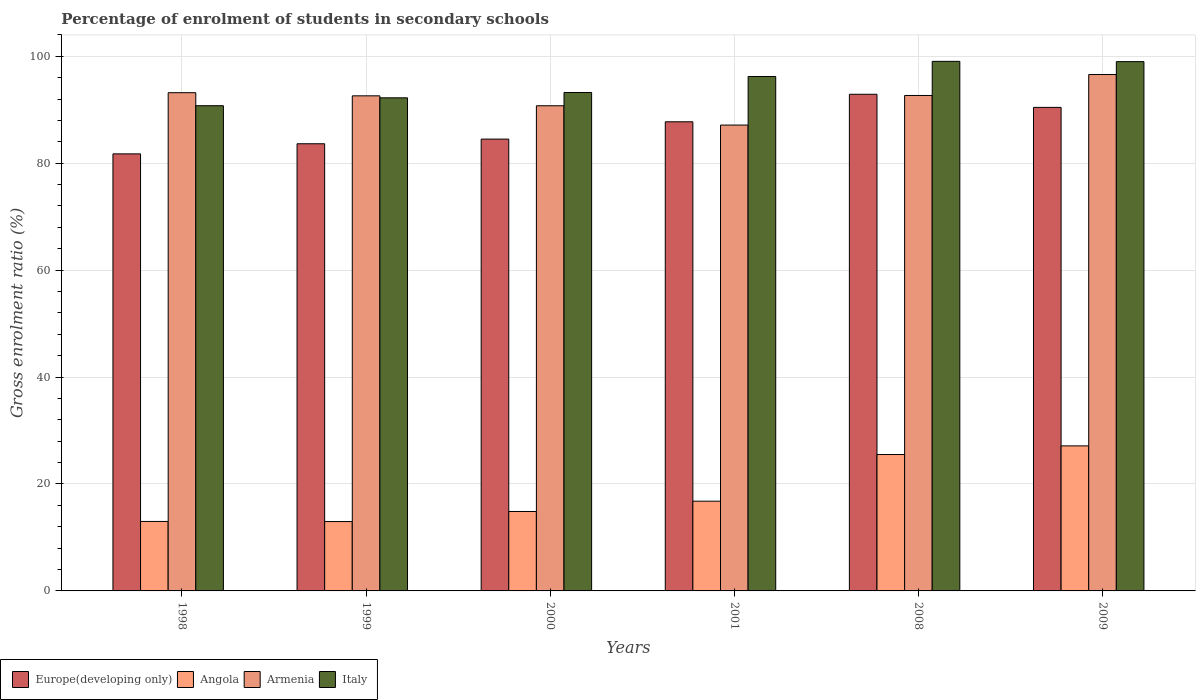How many different coloured bars are there?
Provide a succinct answer. 4. How many groups of bars are there?
Your answer should be very brief. 6. How many bars are there on the 3rd tick from the left?
Your answer should be very brief. 4. In how many cases, is the number of bars for a given year not equal to the number of legend labels?
Give a very brief answer. 0. What is the percentage of students enrolled in secondary schools in Italy in 1999?
Your answer should be very brief. 92.23. Across all years, what is the maximum percentage of students enrolled in secondary schools in Italy?
Your answer should be compact. 99.05. Across all years, what is the minimum percentage of students enrolled in secondary schools in Europe(developing only)?
Your response must be concise. 81.75. In which year was the percentage of students enrolled in secondary schools in Italy maximum?
Offer a terse response. 2008. In which year was the percentage of students enrolled in secondary schools in Armenia minimum?
Ensure brevity in your answer.  2001. What is the total percentage of students enrolled in secondary schools in Italy in the graph?
Provide a succinct answer. 570.5. What is the difference between the percentage of students enrolled in secondary schools in Angola in 2008 and that in 2009?
Ensure brevity in your answer.  -1.62. What is the difference between the percentage of students enrolled in secondary schools in Europe(developing only) in 2008 and the percentage of students enrolled in secondary schools in Angola in 2001?
Your response must be concise. 76.11. What is the average percentage of students enrolled in secondary schools in Armenia per year?
Your answer should be very brief. 92.16. In the year 2009, what is the difference between the percentage of students enrolled in secondary schools in Angola and percentage of students enrolled in secondary schools in Italy?
Offer a very short reply. -71.87. What is the ratio of the percentage of students enrolled in secondary schools in Italy in 1998 to that in 2008?
Your answer should be compact. 0.92. Is the difference between the percentage of students enrolled in secondary schools in Angola in 2000 and 2008 greater than the difference between the percentage of students enrolled in secondary schools in Italy in 2000 and 2008?
Make the answer very short. No. What is the difference between the highest and the second highest percentage of students enrolled in secondary schools in Italy?
Provide a short and direct response. 0.05. What is the difference between the highest and the lowest percentage of students enrolled in secondary schools in Angola?
Offer a terse response. 14.15. What does the 1st bar from the left in 2008 represents?
Provide a succinct answer. Europe(developing only). What does the 3rd bar from the right in 2001 represents?
Give a very brief answer. Angola. Does the graph contain any zero values?
Offer a terse response. No. Where does the legend appear in the graph?
Keep it short and to the point. Bottom left. What is the title of the graph?
Offer a very short reply. Percentage of enrolment of students in secondary schools. What is the label or title of the X-axis?
Your response must be concise. Years. What is the Gross enrolment ratio (%) of Europe(developing only) in 1998?
Offer a terse response. 81.75. What is the Gross enrolment ratio (%) of Angola in 1998?
Ensure brevity in your answer.  12.99. What is the Gross enrolment ratio (%) in Armenia in 1998?
Offer a very short reply. 93.19. What is the Gross enrolment ratio (%) of Italy in 1998?
Your answer should be compact. 90.76. What is the Gross enrolment ratio (%) of Europe(developing only) in 1999?
Ensure brevity in your answer.  83.64. What is the Gross enrolment ratio (%) in Angola in 1999?
Keep it short and to the point. 12.98. What is the Gross enrolment ratio (%) of Armenia in 1999?
Give a very brief answer. 92.6. What is the Gross enrolment ratio (%) in Italy in 1999?
Your answer should be compact. 92.23. What is the Gross enrolment ratio (%) in Europe(developing only) in 2000?
Ensure brevity in your answer.  84.51. What is the Gross enrolment ratio (%) in Angola in 2000?
Your response must be concise. 14.86. What is the Gross enrolment ratio (%) of Armenia in 2000?
Provide a succinct answer. 90.75. What is the Gross enrolment ratio (%) of Italy in 2000?
Provide a short and direct response. 93.23. What is the Gross enrolment ratio (%) of Europe(developing only) in 2001?
Provide a short and direct response. 87.75. What is the Gross enrolment ratio (%) in Angola in 2001?
Your response must be concise. 16.78. What is the Gross enrolment ratio (%) in Armenia in 2001?
Keep it short and to the point. 87.14. What is the Gross enrolment ratio (%) of Italy in 2001?
Your answer should be compact. 96.22. What is the Gross enrolment ratio (%) of Europe(developing only) in 2008?
Provide a short and direct response. 92.9. What is the Gross enrolment ratio (%) of Angola in 2008?
Offer a terse response. 25.51. What is the Gross enrolment ratio (%) in Armenia in 2008?
Your answer should be compact. 92.67. What is the Gross enrolment ratio (%) in Italy in 2008?
Your response must be concise. 99.05. What is the Gross enrolment ratio (%) in Europe(developing only) in 2009?
Offer a very short reply. 90.44. What is the Gross enrolment ratio (%) of Angola in 2009?
Provide a short and direct response. 27.13. What is the Gross enrolment ratio (%) of Armenia in 2009?
Your response must be concise. 96.59. What is the Gross enrolment ratio (%) of Italy in 2009?
Offer a terse response. 99. Across all years, what is the maximum Gross enrolment ratio (%) of Europe(developing only)?
Keep it short and to the point. 92.9. Across all years, what is the maximum Gross enrolment ratio (%) in Angola?
Provide a short and direct response. 27.13. Across all years, what is the maximum Gross enrolment ratio (%) in Armenia?
Keep it short and to the point. 96.59. Across all years, what is the maximum Gross enrolment ratio (%) of Italy?
Your response must be concise. 99.05. Across all years, what is the minimum Gross enrolment ratio (%) of Europe(developing only)?
Provide a short and direct response. 81.75. Across all years, what is the minimum Gross enrolment ratio (%) of Angola?
Offer a very short reply. 12.98. Across all years, what is the minimum Gross enrolment ratio (%) in Armenia?
Ensure brevity in your answer.  87.14. Across all years, what is the minimum Gross enrolment ratio (%) of Italy?
Your response must be concise. 90.76. What is the total Gross enrolment ratio (%) of Europe(developing only) in the graph?
Your answer should be very brief. 520.99. What is the total Gross enrolment ratio (%) of Angola in the graph?
Make the answer very short. 110.25. What is the total Gross enrolment ratio (%) of Armenia in the graph?
Provide a short and direct response. 552.95. What is the total Gross enrolment ratio (%) in Italy in the graph?
Make the answer very short. 570.5. What is the difference between the Gross enrolment ratio (%) of Europe(developing only) in 1998 and that in 1999?
Offer a very short reply. -1.89. What is the difference between the Gross enrolment ratio (%) of Angola in 1998 and that in 1999?
Your answer should be compact. 0.02. What is the difference between the Gross enrolment ratio (%) in Armenia in 1998 and that in 1999?
Provide a succinct answer. 0.59. What is the difference between the Gross enrolment ratio (%) in Italy in 1998 and that in 1999?
Ensure brevity in your answer.  -1.48. What is the difference between the Gross enrolment ratio (%) of Europe(developing only) in 1998 and that in 2000?
Keep it short and to the point. -2.76. What is the difference between the Gross enrolment ratio (%) in Angola in 1998 and that in 2000?
Keep it short and to the point. -1.86. What is the difference between the Gross enrolment ratio (%) in Armenia in 1998 and that in 2000?
Keep it short and to the point. 2.44. What is the difference between the Gross enrolment ratio (%) in Italy in 1998 and that in 2000?
Offer a terse response. -2.47. What is the difference between the Gross enrolment ratio (%) in Europe(developing only) in 1998 and that in 2001?
Make the answer very short. -6. What is the difference between the Gross enrolment ratio (%) in Angola in 1998 and that in 2001?
Your answer should be compact. -3.79. What is the difference between the Gross enrolment ratio (%) in Armenia in 1998 and that in 2001?
Keep it short and to the point. 6.06. What is the difference between the Gross enrolment ratio (%) of Italy in 1998 and that in 2001?
Your answer should be compact. -5.47. What is the difference between the Gross enrolment ratio (%) in Europe(developing only) in 1998 and that in 2008?
Your response must be concise. -11.15. What is the difference between the Gross enrolment ratio (%) of Angola in 1998 and that in 2008?
Your answer should be compact. -12.52. What is the difference between the Gross enrolment ratio (%) in Armenia in 1998 and that in 2008?
Give a very brief answer. 0.52. What is the difference between the Gross enrolment ratio (%) of Italy in 1998 and that in 2008?
Keep it short and to the point. -8.3. What is the difference between the Gross enrolment ratio (%) in Europe(developing only) in 1998 and that in 2009?
Offer a terse response. -8.69. What is the difference between the Gross enrolment ratio (%) of Angola in 1998 and that in 2009?
Your answer should be very brief. -14.13. What is the difference between the Gross enrolment ratio (%) of Armenia in 1998 and that in 2009?
Offer a terse response. -3.4. What is the difference between the Gross enrolment ratio (%) in Italy in 1998 and that in 2009?
Ensure brevity in your answer.  -8.25. What is the difference between the Gross enrolment ratio (%) in Europe(developing only) in 1999 and that in 2000?
Keep it short and to the point. -0.87. What is the difference between the Gross enrolment ratio (%) of Angola in 1999 and that in 2000?
Your answer should be very brief. -1.88. What is the difference between the Gross enrolment ratio (%) of Armenia in 1999 and that in 2000?
Ensure brevity in your answer.  1.85. What is the difference between the Gross enrolment ratio (%) in Italy in 1999 and that in 2000?
Give a very brief answer. -1. What is the difference between the Gross enrolment ratio (%) in Europe(developing only) in 1999 and that in 2001?
Provide a succinct answer. -4.11. What is the difference between the Gross enrolment ratio (%) of Angola in 1999 and that in 2001?
Provide a short and direct response. -3.81. What is the difference between the Gross enrolment ratio (%) of Armenia in 1999 and that in 2001?
Make the answer very short. 5.47. What is the difference between the Gross enrolment ratio (%) in Italy in 1999 and that in 2001?
Make the answer very short. -3.99. What is the difference between the Gross enrolment ratio (%) in Europe(developing only) in 1999 and that in 2008?
Ensure brevity in your answer.  -9.26. What is the difference between the Gross enrolment ratio (%) of Angola in 1999 and that in 2008?
Your answer should be very brief. -12.54. What is the difference between the Gross enrolment ratio (%) of Armenia in 1999 and that in 2008?
Provide a short and direct response. -0.07. What is the difference between the Gross enrolment ratio (%) of Italy in 1999 and that in 2008?
Your answer should be very brief. -6.82. What is the difference between the Gross enrolment ratio (%) of Europe(developing only) in 1999 and that in 2009?
Provide a short and direct response. -6.8. What is the difference between the Gross enrolment ratio (%) of Angola in 1999 and that in 2009?
Make the answer very short. -14.15. What is the difference between the Gross enrolment ratio (%) in Armenia in 1999 and that in 2009?
Make the answer very short. -3.99. What is the difference between the Gross enrolment ratio (%) of Italy in 1999 and that in 2009?
Provide a short and direct response. -6.77. What is the difference between the Gross enrolment ratio (%) of Europe(developing only) in 2000 and that in 2001?
Provide a short and direct response. -3.24. What is the difference between the Gross enrolment ratio (%) in Angola in 2000 and that in 2001?
Your response must be concise. -1.93. What is the difference between the Gross enrolment ratio (%) of Armenia in 2000 and that in 2001?
Provide a succinct answer. 3.61. What is the difference between the Gross enrolment ratio (%) of Italy in 2000 and that in 2001?
Your answer should be compact. -2.99. What is the difference between the Gross enrolment ratio (%) of Europe(developing only) in 2000 and that in 2008?
Keep it short and to the point. -8.38. What is the difference between the Gross enrolment ratio (%) in Angola in 2000 and that in 2008?
Make the answer very short. -10.65. What is the difference between the Gross enrolment ratio (%) in Armenia in 2000 and that in 2008?
Keep it short and to the point. -1.92. What is the difference between the Gross enrolment ratio (%) in Italy in 2000 and that in 2008?
Your answer should be compact. -5.82. What is the difference between the Gross enrolment ratio (%) in Europe(developing only) in 2000 and that in 2009?
Offer a terse response. -5.93. What is the difference between the Gross enrolment ratio (%) of Angola in 2000 and that in 2009?
Give a very brief answer. -12.27. What is the difference between the Gross enrolment ratio (%) in Armenia in 2000 and that in 2009?
Provide a succinct answer. -5.84. What is the difference between the Gross enrolment ratio (%) in Italy in 2000 and that in 2009?
Give a very brief answer. -5.77. What is the difference between the Gross enrolment ratio (%) in Europe(developing only) in 2001 and that in 2008?
Keep it short and to the point. -5.15. What is the difference between the Gross enrolment ratio (%) in Angola in 2001 and that in 2008?
Offer a terse response. -8.73. What is the difference between the Gross enrolment ratio (%) in Armenia in 2001 and that in 2008?
Provide a short and direct response. -5.54. What is the difference between the Gross enrolment ratio (%) of Italy in 2001 and that in 2008?
Your response must be concise. -2.83. What is the difference between the Gross enrolment ratio (%) of Europe(developing only) in 2001 and that in 2009?
Offer a terse response. -2.69. What is the difference between the Gross enrolment ratio (%) of Angola in 2001 and that in 2009?
Keep it short and to the point. -10.34. What is the difference between the Gross enrolment ratio (%) of Armenia in 2001 and that in 2009?
Offer a terse response. -9.45. What is the difference between the Gross enrolment ratio (%) in Italy in 2001 and that in 2009?
Make the answer very short. -2.78. What is the difference between the Gross enrolment ratio (%) in Europe(developing only) in 2008 and that in 2009?
Offer a terse response. 2.45. What is the difference between the Gross enrolment ratio (%) of Angola in 2008 and that in 2009?
Provide a short and direct response. -1.62. What is the difference between the Gross enrolment ratio (%) in Armenia in 2008 and that in 2009?
Ensure brevity in your answer.  -3.92. What is the difference between the Gross enrolment ratio (%) in Italy in 2008 and that in 2009?
Give a very brief answer. 0.05. What is the difference between the Gross enrolment ratio (%) in Europe(developing only) in 1998 and the Gross enrolment ratio (%) in Angola in 1999?
Give a very brief answer. 68.77. What is the difference between the Gross enrolment ratio (%) of Europe(developing only) in 1998 and the Gross enrolment ratio (%) of Armenia in 1999?
Make the answer very short. -10.86. What is the difference between the Gross enrolment ratio (%) of Europe(developing only) in 1998 and the Gross enrolment ratio (%) of Italy in 1999?
Offer a very short reply. -10.48. What is the difference between the Gross enrolment ratio (%) in Angola in 1998 and the Gross enrolment ratio (%) in Armenia in 1999?
Provide a short and direct response. -79.61. What is the difference between the Gross enrolment ratio (%) in Angola in 1998 and the Gross enrolment ratio (%) in Italy in 1999?
Ensure brevity in your answer.  -79.24. What is the difference between the Gross enrolment ratio (%) of Armenia in 1998 and the Gross enrolment ratio (%) of Italy in 1999?
Offer a terse response. 0.96. What is the difference between the Gross enrolment ratio (%) in Europe(developing only) in 1998 and the Gross enrolment ratio (%) in Angola in 2000?
Offer a terse response. 66.89. What is the difference between the Gross enrolment ratio (%) of Europe(developing only) in 1998 and the Gross enrolment ratio (%) of Armenia in 2000?
Make the answer very short. -9. What is the difference between the Gross enrolment ratio (%) of Europe(developing only) in 1998 and the Gross enrolment ratio (%) of Italy in 2000?
Make the answer very short. -11.48. What is the difference between the Gross enrolment ratio (%) in Angola in 1998 and the Gross enrolment ratio (%) in Armenia in 2000?
Offer a terse response. -77.76. What is the difference between the Gross enrolment ratio (%) in Angola in 1998 and the Gross enrolment ratio (%) in Italy in 2000?
Offer a very short reply. -80.24. What is the difference between the Gross enrolment ratio (%) of Armenia in 1998 and the Gross enrolment ratio (%) of Italy in 2000?
Ensure brevity in your answer.  -0.04. What is the difference between the Gross enrolment ratio (%) in Europe(developing only) in 1998 and the Gross enrolment ratio (%) in Angola in 2001?
Make the answer very short. 64.97. What is the difference between the Gross enrolment ratio (%) in Europe(developing only) in 1998 and the Gross enrolment ratio (%) in Armenia in 2001?
Provide a succinct answer. -5.39. What is the difference between the Gross enrolment ratio (%) in Europe(developing only) in 1998 and the Gross enrolment ratio (%) in Italy in 2001?
Your answer should be very brief. -14.47. What is the difference between the Gross enrolment ratio (%) in Angola in 1998 and the Gross enrolment ratio (%) in Armenia in 2001?
Keep it short and to the point. -74.14. What is the difference between the Gross enrolment ratio (%) in Angola in 1998 and the Gross enrolment ratio (%) in Italy in 2001?
Provide a succinct answer. -83.23. What is the difference between the Gross enrolment ratio (%) of Armenia in 1998 and the Gross enrolment ratio (%) of Italy in 2001?
Your answer should be very brief. -3.03. What is the difference between the Gross enrolment ratio (%) of Europe(developing only) in 1998 and the Gross enrolment ratio (%) of Angola in 2008?
Keep it short and to the point. 56.24. What is the difference between the Gross enrolment ratio (%) of Europe(developing only) in 1998 and the Gross enrolment ratio (%) of Armenia in 2008?
Your answer should be compact. -10.92. What is the difference between the Gross enrolment ratio (%) in Europe(developing only) in 1998 and the Gross enrolment ratio (%) in Italy in 2008?
Give a very brief answer. -17.31. What is the difference between the Gross enrolment ratio (%) in Angola in 1998 and the Gross enrolment ratio (%) in Armenia in 2008?
Your answer should be compact. -79.68. What is the difference between the Gross enrolment ratio (%) in Angola in 1998 and the Gross enrolment ratio (%) in Italy in 2008?
Provide a succinct answer. -86.06. What is the difference between the Gross enrolment ratio (%) of Armenia in 1998 and the Gross enrolment ratio (%) of Italy in 2008?
Your response must be concise. -5.86. What is the difference between the Gross enrolment ratio (%) of Europe(developing only) in 1998 and the Gross enrolment ratio (%) of Angola in 2009?
Offer a terse response. 54.62. What is the difference between the Gross enrolment ratio (%) in Europe(developing only) in 1998 and the Gross enrolment ratio (%) in Armenia in 2009?
Ensure brevity in your answer.  -14.84. What is the difference between the Gross enrolment ratio (%) of Europe(developing only) in 1998 and the Gross enrolment ratio (%) of Italy in 2009?
Your answer should be very brief. -17.25. What is the difference between the Gross enrolment ratio (%) of Angola in 1998 and the Gross enrolment ratio (%) of Armenia in 2009?
Offer a very short reply. -83.6. What is the difference between the Gross enrolment ratio (%) of Angola in 1998 and the Gross enrolment ratio (%) of Italy in 2009?
Your answer should be compact. -86.01. What is the difference between the Gross enrolment ratio (%) in Armenia in 1998 and the Gross enrolment ratio (%) in Italy in 2009?
Your answer should be very brief. -5.81. What is the difference between the Gross enrolment ratio (%) in Europe(developing only) in 1999 and the Gross enrolment ratio (%) in Angola in 2000?
Your answer should be compact. 68.78. What is the difference between the Gross enrolment ratio (%) of Europe(developing only) in 1999 and the Gross enrolment ratio (%) of Armenia in 2000?
Provide a short and direct response. -7.11. What is the difference between the Gross enrolment ratio (%) in Europe(developing only) in 1999 and the Gross enrolment ratio (%) in Italy in 2000?
Keep it short and to the point. -9.59. What is the difference between the Gross enrolment ratio (%) in Angola in 1999 and the Gross enrolment ratio (%) in Armenia in 2000?
Give a very brief answer. -77.77. What is the difference between the Gross enrolment ratio (%) in Angola in 1999 and the Gross enrolment ratio (%) in Italy in 2000?
Your answer should be very brief. -80.26. What is the difference between the Gross enrolment ratio (%) of Armenia in 1999 and the Gross enrolment ratio (%) of Italy in 2000?
Offer a terse response. -0.63. What is the difference between the Gross enrolment ratio (%) in Europe(developing only) in 1999 and the Gross enrolment ratio (%) in Angola in 2001?
Make the answer very short. 66.86. What is the difference between the Gross enrolment ratio (%) of Europe(developing only) in 1999 and the Gross enrolment ratio (%) of Armenia in 2001?
Ensure brevity in your answer.  -3.5. What is the difference between the Gross enrolment ratio (%) of Europe(developing only) in 1999 and the Gross enrolment ratio (%) of Italy in 2001?
Your answer should be very brief. -12.58. What is the difference between the Gross enrolment ratio (%) of Angola in 1999 and the Gross enrolment ratio (%) of Armenia in 2001?
Give a very brief answer. -74.16. What is the difference between the Gross enrolment ratio (%) in Angola in 1999 and the Gross enrolment ratio (%) in Italy in 2001?
Your answer should be very brief. -83.25. What is the difference between the Gross enrolment ratio (%) of Armenia in 1999 and the Gross enrolment ratio (%) of Italy in 2001?
Offer a terse response. -3.62. What is the difference between the Gross enrolment ratio (%) in Europe(developing only) in 1999 and the Gross enrolment ratio (%) in Angola in 2008?
Your response must be concise. 58.13. What is the difference between the Gross enrolment ratio (%) in Europe(developing only) in 1999 and the Gross enrolment ratio (%) in Armenia in 2008?
Ensure brevity in your answer.  -9.03. What is the difference between the Gross enrolment ratio (%) of Europe(developing only) in 1999 and the Gross enrolment ratio (%) of Italy in 2008?
Make the answer very short. -15.41. What is the difference between the Gross enrolment ratio (%) in Angola in 1999 and the Gross enrolment ratio (%) in Armenia in 2008?
Offer a terse response. -79.7. What is the difference between the Gross enrolment ratio (%) of Angola in 1999 and the Gross enrolment ratio (%) of Italy in 2008?
Offer a terse response. -86.08. What is the difference between the Gross enrolment ratio (%) of Armenia in 1999 and the Gross enrolment ratio (%) of Italy in 2008?
Give a very brief answer. -6.45. What is the difference between the Gross enrolment ratio (%) in Europe(developing only) in 1999 and the Gross enrolment ratio (%) in Angola in 2009?
Ensure brevity in your answer.  56.51. What is the difference between the Gross enrolment ratio (%) of Europe(developing only) in 1999 and the Gross enrolment ratio (%) of Armenia in 2009?
Make the answer very short. -12.95. What is the difference between the Gross enrolment ratio (%) in Europe(developing only) in 1999 and the Gross enrolment ratio (%) in Italy in 2009?
Your response must be concise. -15.36. What is the difference between the Gross enrolment ratio (%) in Angola in 1999 and the Gross enrolment ratio (%) in Armenia in 2009?
Your response must be concise. -83.62. What is the difference between the Gross enrolment ratio (%) of Angola in 1999 and the Gross enrolment ratio (%) of Italy in 2009?
Keep it short and to the point. -86.03. What is the difference between the Gross enrolment ratio (%) of Armenia in 1999 and the Gross enrolment ratio (%) of Italy in 2009?
Offer a very short reply. -6.4. What is the difference between the Gross enrolment ratio (%) of Europe(developing only) in 2000 and the Gross enrolment ratio (%) of Angola in 2001?
Offer a very short reply. 67.73. What is the difference between the Gross enrolment ratio (%) in Europe(developing only) in 2000 and the Gross enrolment ratio (%) in Armenia in 2001?
Keep it short and to the point. -2.62. What is the difference between the Gross enrolment ratio (%) of Europe(developing only) in 2000 and the Gross enrolment ratio (%) of Italy in 2001?
Offer a very short reply. -11.71. What is the difference between the Gross enrolment ratio (%) of Angola in 2000 and the Gross enrolment ratio (%) of Armenia in 2001?
Offer a terse response. -72.28. What is the difference between the Gross enrolment ratio (%) of Angola in 2000 and the Gross enrolment ratio (%) of Italy in 2001?
Provide a succinct answer. -81.36. What is the difference between the Gross enrolment ratio (%) in Armenia in 2000 and the Gross enrolment ratio (%) in Italy in 2001?
Your answer should be very brief. -5.47. What is the difference between the Gross enrolment ratio (%) in Europe(developing only) in 2000 and the Gross enrolment ratio (%) in Angola in 2008?
Provide a short and direct response. 59. What is the difference between the Gross enrolment ratio (%) in Europe(developing only) in 2000 and the Gross enrolment ratio (%) in Armenia in 2008?
Ensure brevity in your answer.  -8.16. What is the difference between the Gross enrolment ratio (%) of Europe(developing only) in 2000 and the Gross enrolment ratio (%) of Italy in 2008?
Offer a very short reply. -14.54. What is the difference between the Gross enrolment ratio (%) of Angola in 2000 and the Gross enrolment ratio (%) of Armenia in 2008?
Your answer should be very brief. -77.81. What is the difference between the Gross enrolment ratio (%) of Angola in 2000 and the Gross enrolment ratio (%) of Italy in 2008?
Your answer should be very brief. -84.2. What is the difference between the Gross enrolment ratio (%) of Armenia in 2000 and the Gross enrolment ratio (%) of Italy in 2008?
Offer a very short reply. -8.3. What is the difference between the Gross enrolment ratio (%) in Europe(developing only) in 2000 and the Gross enrolment ratio (%) in Angola in 2009?
Provide a succinct answer. 57.38. What is the difference between the Gross enrolment ratio (%) in Europe(developing only) in 2000 and the Gross enrolment ratio (%) in Armenia in 2009?
Provide a short and direct response. -12.08. What is the difference between the Gross enrolment ratio (%) of Europe(developing only) in 2000 and the Gross enrolment ratio (%) of Italy in 2009?
Give a very brief answer. -14.49. What is the difference between the Gross enrolment ratio (%) in Angola in 2000 and the Gross enrolment ratio (%) in Armenia in 2009?
Make the answer very short. -81.73. What is the difference between the Gross enrolment ratio (%) of Angola in 2000 and the Gross enrolment ratio (%) of Italy in 2009?
Offer a terse response. -84.14. What is the difference between the Gross enrolment ratio (%) in Armenia in 2000 and the Gross enrolment ratio (%) in Italy in 2009?
Your response must be concise. -8.25. What is the difference between the Gross enrolment ratio (%) of Europe(developing only) in 2001 and the Gross enrolment ratio (%) of Angola in 2008?
Ensure brevity in your answer.  62.24. What is the difference between the Gross enrolment ratio (%) of Europe(developing only) in 2001 and the Gross enrolment ratio (%) of Armenia in 2008?
Offer a very short reply. -4.92. What is the difference between the Gross enrolment ratio (%) of Europe(developing only) in 2001 and the Gross enrolment ratio (%) of Italy in 2008?
Make the answer very short. -11.3. What is the difference between the Gross enrolment ratio (%) in Angola in 2001 and the Gross enrolment ratio (%) in Armenia in 2008?
Your answer should be very brief. -75.89. What is the difference between the Gross enrolment ratio (%) in Angola in 2001 and the Gross enrolment ratio (%) in Italy in 2008?
Offer a very short reply. -82.27. What is the difference between the Gross enrolment ratio (%) in Armenia in 2001 and the Gross enrolment ratio (%) in Italy in 2008?
Your response must be concise. -11.92. What is the difference between the Gross enrolment ratio (%) of Europe(developing only) in 2001 and the Gross enrolment ratio (%) of Angola in 2009?
Make the answer very short. 60.62. What is the difference between the Gross enrolment ratio (%) of Europe(developing only) in 2001 and the Gross enrolment ratio (%) of Armenia in 2009?
Offer a terse response. -8.84. What is the difference between the Gross enrolment ratio (%) of Europe(developing only) in 2001 and the Gross enrolment ratio (%) of Italy in 2009?
Offer a terse response. -11.25. What is the difference between the Gross enrolment ratio (%) in Angola in 2001 and the Gross enrolment ratio (%) in Armenia in 2009?
Your response must be concise. -79.81. What is the difference between the Gross enrolment ratio (%) of Angola in 2001 and the Gross enrolment ratio (%) of Italy in 2009?
Your answer should be compact. -82.22. What is the difference between the Gross enrolment ratio (%) of Armenia in 2001 and the Gross enrolment ratio (%) of Italy in 2009?
Make the answer very short. -11.87. What is the difference between the Gross enrolment ratio (%) of Europe(developing only) in 2008 and the Gross enrolment ratio (%) of Angola in 2009?
Provide a short and direct response. 65.77. What is the difference between the Gross enrolment ratio (%) in Europe(developing only) in 2008 and the Gross enrolment ratio (%) in Armenia in 2009?
Offer a terse response. -3.69. What is the difference between the Gross enrolment ratio (%) of Europe(developing only) in 2008 and the Gross enrolment ratio (%) of Italy in 2009?
Keep it short and to the point. -6.11. What is the difference between the Gross enrolment ratio (%) in Angola in 2008 and the Gross enrolment ratio (%) in Armenia in 2009?
Make the answer very short. -71.08. What is the difference between the Gross enrolment ratio (%) in Angola in 2008 and the Gross enrolment ratio (%) in Italy in 2009?
Your answer should be very brief. -73.49. What is the difference between the Gross enrolment ratio (%) in Armenia in 2008 and the Gross enrolment ratio (%) in Italy in 2009?
Keep it short and to the point. -6.33. What is the average Gross enrolment ratio (%) of Europe(developing only) per year?
Offer a very short reply. 86.83. What is the average Gross enrolment ratio (%) in Angola per year?
Ensure brevity in your answer.  18.38. What is the average Gross enrolment ratio (%) of Armenia per year?
Ensure brevity in your answer.  92.16. What is the average Gross enrolment ratio (%) in Italy per year?
Your answer should be compact. 95.08. In the year 1998, what is the difference between the Gross enrolment ratio (%) of Europe(developing only) and Gross enrolment ratio (%) of Angola?
Your response must be concise. 68.76. In the year 1998, what is the difference between the Gross enrolment ratio (%) of Europe(developing only) and Gross enrolment ratio (%) of Armenia?
Provide a succinct answer. -11.44. In the year 1998, what is the difference between the Gross enrolment ratio (%) in Europe(developing only) and Gross enrolment ratio (%) in Italy?
Ensure brevity in your answer.  -9.01. In the year 1998, what is the difference between the Gross enrolment ratio (%) of Angola and Gross enrolment ratio (%) of Armenia?
Make the answer very short. -80.2. In the year 1998, what is the difference between the Gross enrolment ratio (%) of Angola and Gross enrolment ratio (%) of Italy?
Give a very brief answer. -77.76. In the year 1998, what is the difference between the Gross enrolment ratio (%) in Armenia and Gross enrolment ratio (%) in Italy?
Offer a terse response. 2.44. In the year 1999, what is the difference between the Gross enrolment ratio (%) of Europe(developing only) and Gross enrolment ratio (%) of Angola?
Keep it short and to the point. 70.66. In the year 1999, what is the difference between the Gross enrolment ratio (%) of Europe(developing only) and Gross enrolment ratio (%) of Armenia?
Ensure brevity in your answer.  -8.96. In the year 1999, what is the difference between the Gross enrolment ratio (%) in Europe(developing only) and Gross enrolment ratio (%) in Italy?
Provide a short and direct response. -8.59. In the year 1999, what is the difference between the Gross enrolment ratio (%) of Angola and Gross enrolment ratio (%) of Armenia?
Offer a very short reply. -79.63. In the year 1999, what is the difference between the Gross enrolment ratio (%) of Angola and Gross enrolment ratio (%) of Italy?
Offer a terse response. -79.26. In the year 1999, what is the difference between the Gross enrolment ratio (%) in Armenia and Gross enrolment ratio (%) in Italy?
Your answer should be very brief. 0.37. In the year 2000, what is the difference between the Gross enrolment ratio (%) in Europe(developing only) and Gross enrolment ratio (%) in Angola?
Ensure brevity in your answer.  69.65. In the year 2000, what is the difference between the Gross enrolment ratio (%) of Europe(developing only) and Gross enrolment ratio (%) of Armenia?
Make the answer very short. -6.24. In the year 2000, what is the difference between the Gross enrolment ratio (%) of Europe(developing only) and Gross enrolment ratio (%) of Italy?
Ensure brevity in your answer.  -8.72. In the year 2000, what is the difference between the Gross enrolment ratio (%) in Angola and Gross enrolment ratio (%) in Armenia?
Provide a short and direct response. -75.89. In the year 2000, what is the difference between the Gross enrolment ratio (%) in Angola and Gross enrolment ratio (%) in Italy?
Keep it short and to the point. -78.37. In the year 2000, what is the difference between the Gross enrolment ratio (%) of Armenia and Gross enrolment ratio (%) of Italy?
Your response must be concise. -2.48. In the year 2001, what is the difference between the Gross enrolment ratio (%) in Europe(developing only) and Gross enrolment ratio (%) in Angola?
Ensure brevity in your answer.  70.97. In the year 2001, what is the difference between the Gross enrolment ratio (%) of Europe(developing only) and Gross enrolment ratio (%) of Armenia?
Give a very brief answer. 0.61. In the year 2001, what is the difference between the Gross enrolment ratio (%) of Europe(developing only) and Gross enrolment ratio (%) of Italy?
Offer a terse response. -8.47. In the year 2001, what is the difference between the Gross enrolment ratio (%) of Angola and Gross enrolment ratio (%) of Armenia?
Offer a terse response. -70.35. In the year 2001, what is the difference between the Gross enrolment ratio (%) in Angola and Gross enrolment ratio (%) in Italy?
Your answer should be compact. -79.44. In the year 2001, what is the difference between the Gross enrolment ratio (%) in Armenia and Gross enrolment ratio (%) in Italy?
Provide a succinct answer. -9.09. In the year 2008, what is the difference between the Gross enrolment ratio (%) in Europe(developing only) and Gross enrolment ratio (%) in Angola?
Give a very brief answer. 67.38. In the year 2008, what is the difference between the Gross enrolment ratio (%) in Europe(developing only) and Gross enrolment ratio (%) in Armenia?
Offer a very short reply. 0.22. In the year 2008, what is the difference between the Gross enrolment ratio (%) of Europe(developing only) and Gross enrolment ratio (%) of Italy?
Provide a succinct answer. -6.16. In the year 2008, what is the difference between the Gross enrolment ratio (%) in Angola and Gross enrolment ratio (%) in Armenia?
Keep it short and to the point. -67.16. In the year 2008, what is the difference between the Gross enrolment ratio (%) of Angola and Gross enrolment ratio (%) of Italy?
Ensure brevity in your answer.  -73.54. In the year 2008, what is the difference between the Gross enrolment ratio (%) of Armenia and Gross enrolment ratio (%) of Italy?
Offer a terse response. -6.38. In the year 2009, what is the difference between the Gross enrolment ratio (%) of Europe(developing only) and Gross enrolment ratio (%) of Angola?
Provide a succinct answer. 63.32. In the year 2009, what is the difference between the Gross enrolment ratio (%) of Europe(developing only) and Gross enrolment ratio (%) of Armenia?
Provide a short and direct response. -6.15. In the year 2009, what is the difference between the Gross enrolment ratio (%) in Europe(developing only) and Gross enrolment ratio (%) in Italy?
Your answer should be compact. -8.56. In the year 2009, what is the difference between the Gross enrolment ratio (%) of Angola and Gross enrolment ratio (%) of Armenia?
Give a very brief answer. -69.46. In the year 2009, what is the difference between the Gross enrolment ratio (%) of Angola and Gross enrolment ratio (%) of Italy?
Make the answer very short. -71.87. In the year 2009, what is the difference between the Gross enrolment ratio (%) of Armenia and Gross enrolment ratio (%) of Italy?
Your answer should be compact. -2.41. What is the ratio of the Gross enrolment ratio (%) of Europe(developing only) in 1998 to that in 1999?
Keep it short and to the point. 0.98. What is the ratio of the Gross enrolment ratio (%) of Angola in 1998 to that in 1999?
Offer a very short reply. 1. What is the ratio of the Gross enrolment ratio (%) of Armenia in 1998 to that in 1999?
Give a very brief answer. 1.01. What is the ratio of the Gross enrolment ratio (%) of Europe(developing only) in 1998 to that in 2000?
Provide a succinct answer. 0.97. What is the ratio of the Gross enrolment ratio (%) of Angola in 1998 to that in 2000?
Offer a very short reply. 0.87. What is the ratio of the Gross enrolment ratio (%) of Armenia in 1998 to that in 2000?
Your response must be concise. 1.03. What is the ratio of the Gross enrolment ratio (%) in Italy in 1998 to that in 2000?
Provide a short and direct response. 0.97. What is the ratio of the Gross enrolment ratio (%) of Europe(developing only) in 1998 to that in 2001?
Keep it short and to the point. 0.93. What is the ratio of the Gross enrolment ratio (%) of Angola in 1998 to that in 2001?
Ensure brevity in your answer.  0.77. What is the ratio of the Gross enrolment ratio (%) in Armenia in 1998 to that in 2001?
Give a very brief answer. 1.07. What is the ratio of the Gross enrolment ratio (%) of Italy in 1998 to that in 2001?
Offer a terse response. 0.94. What is the ratio of the Gross enrolment ratio (%) in Angola in 1998 to that in 2008?
Keep it short and to the point. 0.51. What is the ratio of the Gross enrolment ratio (%) of Armenia in 1998 to that in 2008?
Offer a terse response. 1.01. What is the ratio of the Gross enrolment ratio (%) in Italy in 1998 to that in 2008?
Keep it short and to the point. 0.92. What is the ratio of the Gross enrolment ratio (%) of Europe(developing only) in 1998 to that in 2009?
Your answer should be very brief. 0.9. What is the ratio of the Gross enrolment ratio (%) in Angola in 1998 to that in 2009?
Keep it short and to the point. 0.48. What is the ratio of the Gross enrolment ratio (%) of Armenia in 1998 to that in 2009?
Provide a short and direct response. 0.96. What is the ratio of the Gross enrolment ratio (%) in Italy in 1998 to that in 2009?
Give a very brief answer. 0.92. What is the ratio of the Gross enrolment ratio (%) of Europe(developing only) in 1999 to that in 2000?
Offer a very short reply. 0.99. What is the ratio of the Gross enrolment ratio (%) in Angola in 1999 to that in 2000?
Keep it short and to the point. 0.87. What is the ratio of the Gross enrolment ratio (%) of Armenia in 1999 to that in 2000?
Your answer should be very brief. 1.02. What is the ratio of the Gross enrolment ratio (%) in Italy in 1999 to that in 2000?
Offer a terse response. 0.99. What is the ratio of the Gross enrolment ratio (%) of Europe(developing only) in 1999 to that in 2001?
Provide a short and direct response. 0.95. What is the ratio of the Gross enrolment ratio (%) of Angola in 1999 to that in 2001?
Give a very brief answer. 0.77. What is the ratio of the Gross enrolment ratio (%) of Armenia in 1999 to that in 2001?
Give a very brief answer. 1.06. What is the ratio of the Gross enrolment ratio (%) of Italy in 1999 to that in 2001?
Your answer should be very brief. 0.96. What is the ratio of the Gross enrolment ratio (%) in Europe(developing only) in 1999 to that in 2008?
Make the answer very short. 0.9. What is the ratio of the Gross enrolment ratio (%) in Angola in 1999 to that in 2008?
Ensure brevity in your answer.  0.51. What is the ratio of the Gross enrolment ratio (%) of Armenia in 1999 to that in 2008?
Provide a short and direct response. 1. What is the ratio of the Gross enrolment ratio (%) in Italy in 1999 to that in 2008?
Provide a short and direct response. 0.93. What is the ratio of the Gross enrolment ratio (%) in Europe(developing only) in 1999 to that in 2009?
Your response must be concise. 0.92. What is the ratio of the Gross enrolment ratio (%) in Angola in 1999 to that in 2009?
Offer a terse response. 0.48. What is the ratio of the Gross enrolment ratio (%) of Armenia in 1999 to that in 2009?
Your response must be concise. 0.96. What is the ratio of the Gross enrolment ratio (%) of Italy in 1999 to that in 2009?
Provide a short and direct response. 0.93. What is the ratio of the Gross enrolment ratio (%) of Europe(developing only) in 2000 to that in 2001?
Keep it short and to the point. 0.96. What is the ratio of the Gross enrolment ratio (%) in Angola in 2000 to that in 2001?
Keep it short and to the point. 0.89. What is the ratio of the Gross enrolment ratio (%) in Armenia in 2000 to that in 2001?
Provide a succinct answer. 1.04. What is the ratio of the Gross enrolment ratio (%) in Italy in 2000 to that in 2001?
Your answer should be very brief. 0.97. What is the ratio of the Gross enrolment ratio (%) in Europe(developing only) in 2000 to that in 2008?
Make the answer very short. 0.91. What is the ratio of the Gross enrolment ratio (%) in Angola in 2000 to that in 2008?
Ensure brevity in your answer.  0.58. What is the ratio of the Gross enrolment ratio (%) of Armenia in 2000 to that in 2008?
Make the answer very short. 0.98. What is the ratio of the Gross enrolment ratio (%) of Europe(developing only) in 2000 to that in 2009?
Your response must be concise. 0.93. What is the ratio of the Gross enrolment ratio (%) in Angola in 2000 to that in 2009?
Provide a succinct answer. 0.55. What is the ratio of the Gross enrolment ratio (%) of Armenia in 2000 to that in 2009?
Make the answer very short. 0.94. What is the ratio of the Gross enrolment ratio (%) of Italy in 2000 to that in 2009?
Your answer should be compact. 0.94. What is the ratio of the Gross enrolment ratio (%) in Europe(developing only) in 2001 to that in 2008?
Provide a succinct answer. 0.94. What is the ratio of the Gross enrolment ratio (%) in Angola in 2001 to that in 2008?
Give a very brief answer. 0.66. What is the ratio of the Gross enrolment ratio (%) of Armenia in 2001 to that in 2008?
Your answer should be very brief. 0.94. What is the ratio of the Gross enrolment ratio (%) of Italy in 2001 to that in 2008?
Keep it short and to the point. 0.97. What is the ratio of the Gross enrolment ratio (%) of Europe(developing only) in 2001 to that in 2009?
Offer a very short reply. 0.97. What is the ratio of the Gross enrolment ratio (%) of Angola in 2001 to that in 2009?
Your response must be concise. 0.62. What is the ratio of the Gross enrolment ratio (%) in Armenia in 2001 to that in 2009?
Ensure brevity in your answer.  0.9. What is the ratio of the Gross enrolment ratio (%) of Italy in 2001 to that in 2009?
Offer a very short reply. 0.97. What is the ratio of the Gross enrolment ratio (%) in Europe(developing only) in 2008 to that in 2009?
Your answer should be very brief. 1.03. What is the ratio of the Gross enrolment ratio (%) of Angola in 2008 to that in 2009?
Your response must be concise. 0.94. What is the ratio of the Gross enrolment ratio (%) of Armenia in 2008 to that in 2009?
Keep it short and to the point. 0.96. What is the difference between the highest and the second highest Gross enrolment ratio (%) in Europe(developing only)?
Offer a terse response. 2.45. What is the difference between the highest and the second highest Gross enrolment ratio (%) in Angola?
Provide a succinct answer. 1.62. What is the difference between the highest and the second highest Gross enrolment ratio (%) of Armenia?
Offer a terse response. 3.4. What is the difference between the highest and the second highest Gross enrolment ratio (%) of Italy?
Ensure brevity in your answer.  0.05. What is the difference between the highest and the lowest Gross enrolment ratio (%) of Europe(developing only)?
Your answer should be very brief. 11.15. What is the difference between the highest and the lowest Gross enrolment ratio (%) in Angola?
Give a very brief answer. 14.15. What is the difference between the highest and the lowest Gross enrolment ratio (%) in Armenia?
Your answer should be compact. 9.45. What is the difference between the highest and the lowest Gross enrolment ratio (%) of Italy?
Offer a terse response. 8.3. 